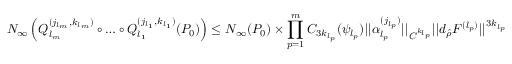<formula> <loc_0><loc_0><loc_500><loc_500>N _ { \infty } \left ( Q _ { l _ { m } } ^ { ( j _ { l _ { m } } , k _ { l _ { m } } ) } \circ \dots \circ Q _ { l _ { 1 } } ^ { ( j _ { l _ { 1 } } , k _ { l _ { 1 } } ) } ( P _ { 0 } ) \right ) \leq N _ { \infty } ( P _ { 0 } ) \times \prod _ { p = 1 } ^ { m } C _ { 3 k _ { l _ { p } } } ( \psi _ { l _ { p } } ) | | \alpha _ { l _ { p } } ^ { ( j _ { l _ { p } } ) } | | _ { C ^ { k _ { l _ { p } } } } | | d _ { \hat { \rho } } F ^ { ( l _ { p } ) } | | ^ { 3 k _ { l _ { p } } }</formula> 